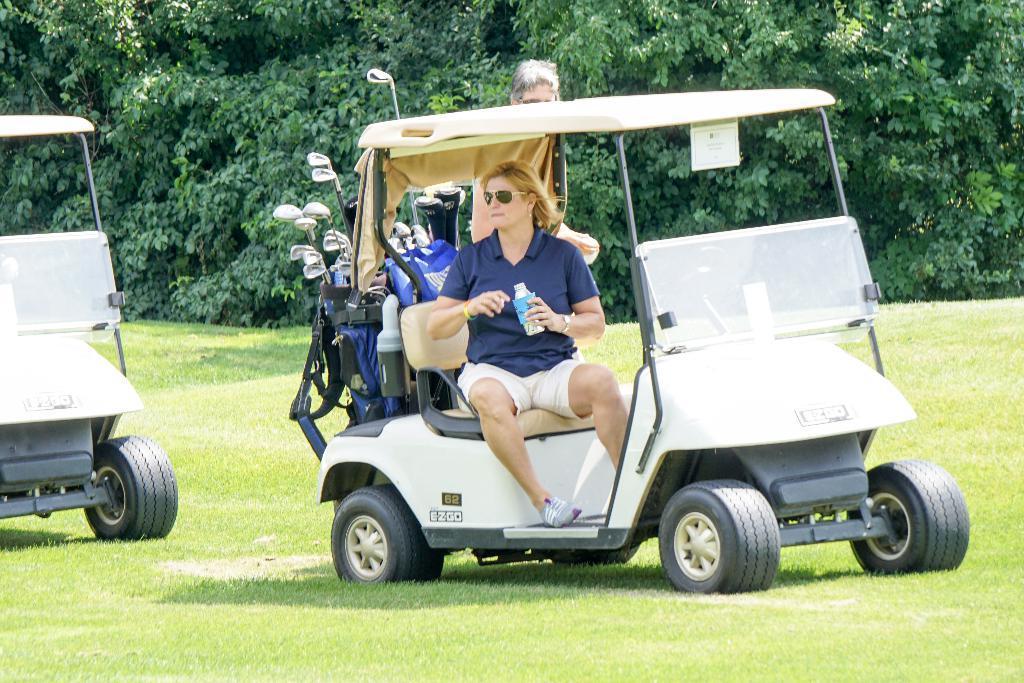How would you summarize this image in a sentence or two? In this image I can see two people and many golf-sticks in the vehicle. To the left I can see an another vehicle. These are on the ground. In the background I can see many trees. 